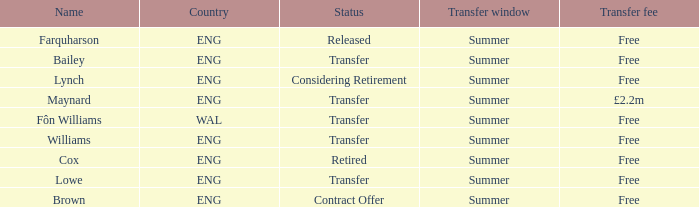What is the status of the ENG Country with the name of Farquharson? Released. 